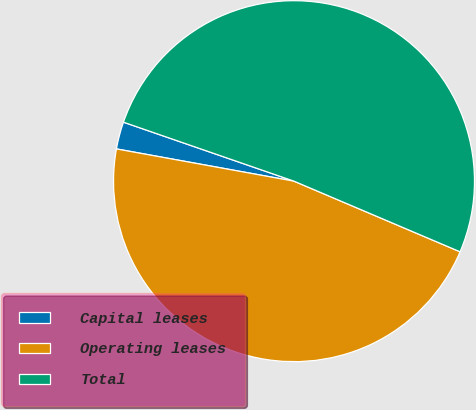Convert chart. <chart><loc_0><loc_0><loc_500><loc_500><pie_chart><fcel>Capital leases<fcel>Operating leases<fcel>Total<nl><fcel>2.44%<fcel>46.46%<fcel>51.1%<nl></chart> 